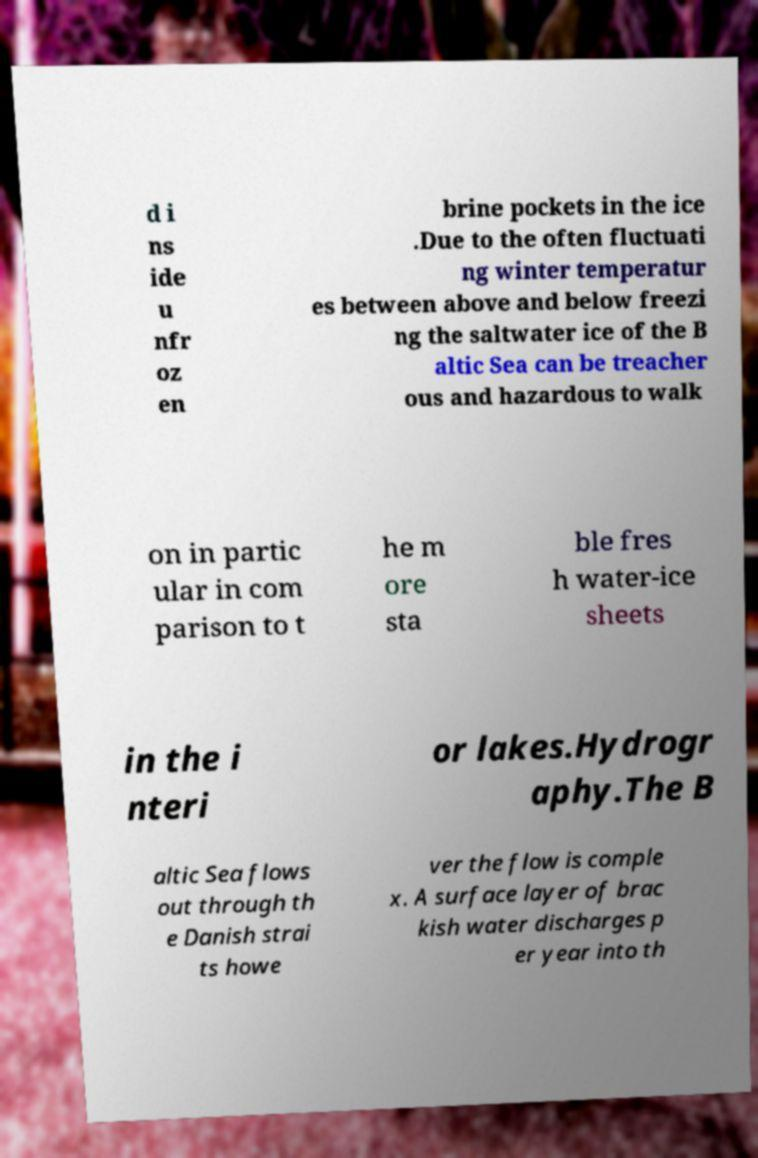Please identify and transcribe the text found in this image. d i ns ide u nfr oz en brine pockets in the ice .Due to the often fluctuati ng winter temperatur es between above and below freezi ng the saltwater ice of the B altic Sea can be treacher ous and hazardous to walk on in partic ular in com parison to t he m ore sta ble fres h water-ice sheets in the i nteri or lakes.Hydrogr aphy.The B altic Sea flows out through th e Danish strai ts howe ver the flow is comple x. A surface layer of brac kish water discharges p er year into th 